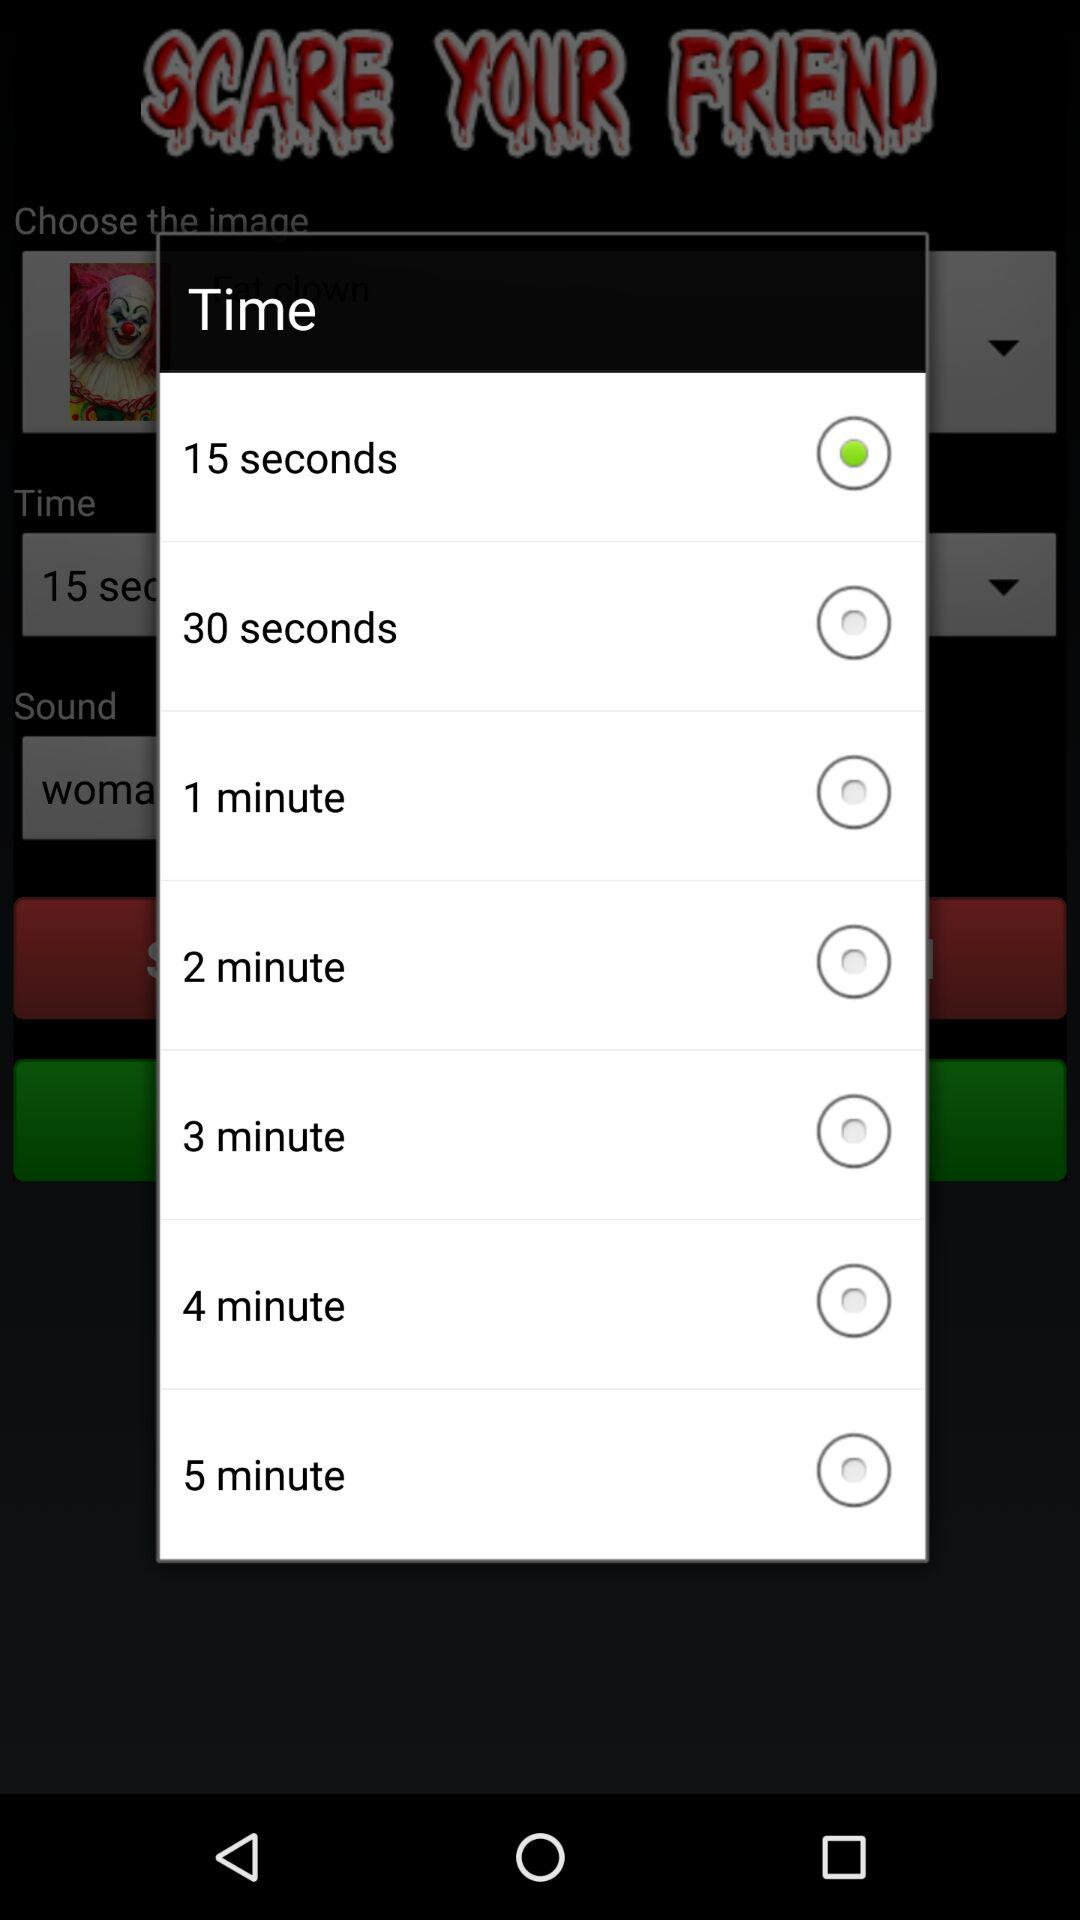What is the selected option in "Time"? The selected option is "15 seconds". 